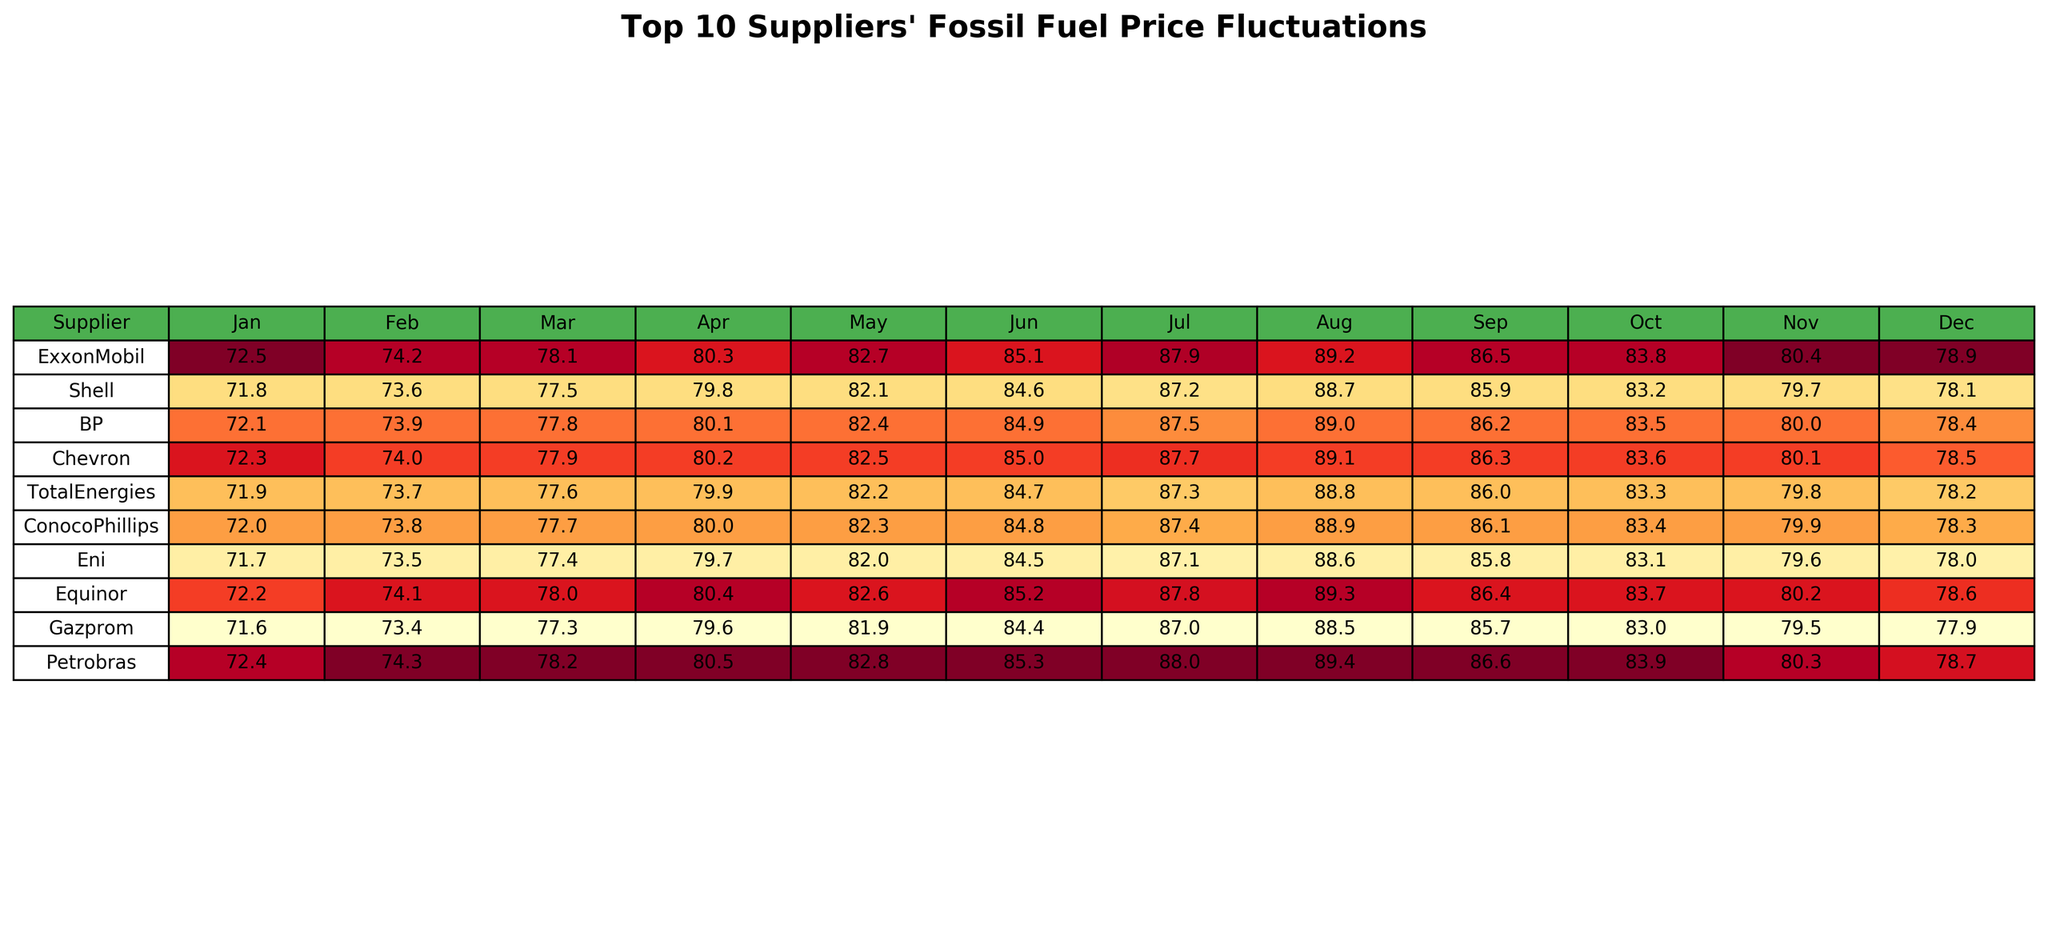What was the highest fossil fuel price among the suppliers in December? By examining the last column for December, the prices for each supplier are: ExxonMobil (78.9), Shell (78.1), BP (78.4), Chevron (78.5), TotalEnergies (78.2), ConocoPhillips (78.3), Eni (78.0), Equinor (78.6), Gazprom (77.9), and Petrobras (78.7). The highest value is 78.9 from ExxonMobil.
Answer: 78.9 Which supplier experienced the largest price increase from January to December? First, we find the difference between the prices in January and December for each supplier. Calculating these differences: ExxonMobil (78.9 - 72.5 = 6.4), Shell (78.1 - 71.8 = 6.3), BP (78.4 - 72.1 = 6.3), Chevron (78.5 - 72.3 = 6.2), TotalEnergies (78.2 - 71.9 = 6.3), ConocoPhillips (78.3 - 72.0 = 6.3), Eni (78.0 - 71.7 = 6.3), Equinor (78.6 - 72.2 = 6.4), Gazprom (77.9 - 71.6 = 6.3), and Petrobras (78.7 - 72.4 = 6.3). The largest increase is found at both ExxonMobil and Equinor with a difference of 6.4.
Answer: ExxonMobil and Equinor What was the average fossil fuel price for BP throughout the year? To calculate BP's average price, we sum up all monthly prices: (72.1 + 73.9 + 77.8 + 80.1 + 82.4 + 84.9 + 87.5 + 89.0 + 86.2 + 83.5 + 80.0 + 78.4 =  1,015.8). Then we divide this by 12 (the number of months), resulting in an average of 1,015.8 / 12 = 84.65.
Answer: 84.65 Did Gazprom have the lowest price in any month? By checking each month for the lowest price for any supplier, we see Gazprom had the lowest in January (71.6) compared to others.
Answer: Yes What is the median price for TotalEnergies across the year? First, we list TotalEnergies' prices: 71.9, 73.7, 77.6, 79.9, 82.2, 84.7, 87.3, 88.8, 86.0, 83.3, 79.8, 78.2. Arranging these values from smallest to largest gives: 71.9, 73.7, 77.6, 78.2, 79.8, 79.9, 82.2, 83.3, 84.7, 86.0, 87.3, 88.8. The median is the average of the 6th and 7th numbers: (79.9 + 82.2) / 2 = 81.05.
Answer: 81.05 Which supplier had the most price fluctuations based on the year’s data? To find fluctuations, we calculate the range for each supplier by subtracting their lowest price from the highest. Examining the ranges: ExxonMobil (89.2 - 72.5 = 16.7), Shell (88.7 - 71.8 = 16.9), BP (89.0 - 72.1 = 16.9), Chevron (89.1 - 72.3 = 16.8), TotalEnergies (88.8 - 71.9 = 16.9), ConocoPhillips (88.9 - 72.0 = 16.9), Eni (88.6 - 71.7 = 16.9), Equinor (89.3 - 72.2 = 17.1), Gazprom (88.5 - 71.6 = 16.9), and Petrobras (89.4 - 72.4 = 17.0). Equinor has the largest fluctuation with a range of 17.1.
Answer: Equinor What was Shell's price change in October compared to January? The price in January was 71.8, and in October it was 83.2. The change is calculated as 83.2 - 71.8 = 11.4.
Answer: 11.4 Which supplier consistently stayed below 80 throughout the first half of the year? Checking the prices from January to June for each supplier reveals that Eni stayed below 80: (71.7, 73.5, 77.4, 79.7, 82.0, 84.5). The prices in May and June exceed 80, thus only considering until April, Eni remained consistently below 80.
Answer: Eni (until April) What percentage did Chevron's price increase from the lowest to highest month within the year? The lowest price was in January at 72.3 and the highest price in July at 89.1. Calculating the increase gives: (89.1 - 72.3) / 72.3 * 100 = 23.2%.
Answer: 23.2% 